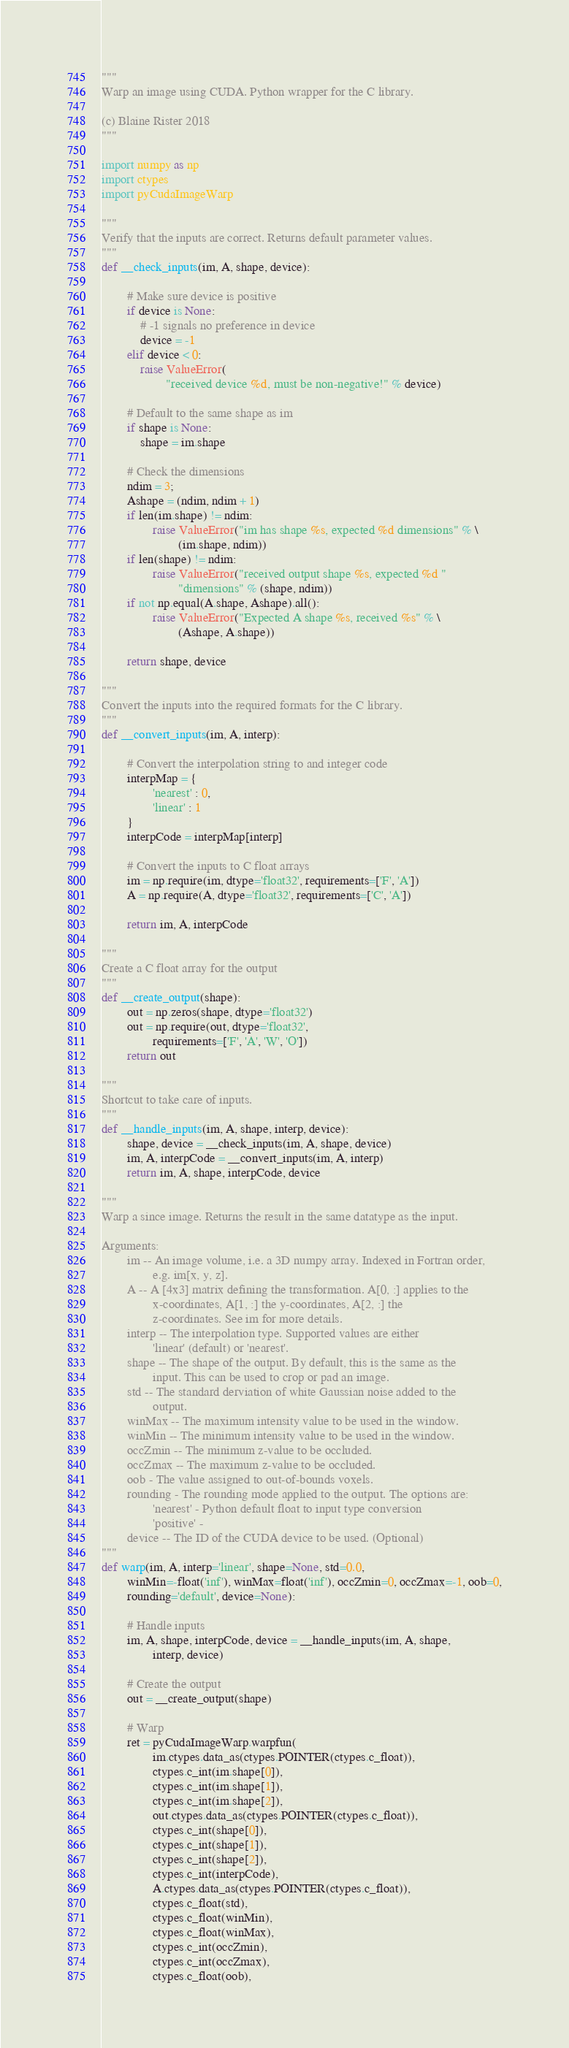<code> <loc_0><loc_0><loc_500><loc_500><_Python_>"""
Warp an image using CUDA. Python wrapper for the C library.

(c) Blaine Rister 2018
"""

import numpy as np
import ctypes
import pyCudaImageWarp

"""
Verify that the inputs are correct. Returns default parameter values.
"""
def __check_inputs(im, A, shape, device):

        # Make sure device is positive
        if device is None:
            # -1 signals no preference in device
            device = -1
        elif device < 0:
            raise ValueError(
                    "received device %d, must be non-negative!" % device)

        # Default to the same shape as im
        if shape is None:
            shape = im.shape

        # Check the dimensions
        ndim = 3;
        Ashape = (ndim, ndim + 1)
        if len(im.shape) != ndim:
                raise ValueError("im has shape %s, expected %d dimensions" % \
                        (im.shape, ndim))
        if len(shape) != ndim:
                raise ValueError("received output shape %s, expected %d "
                        "dimensions" % (shape, ndim))
        if not np.equal(A.shape, Ashape).all():
                raise ValueError("Expected A shape %s, received %s" % \
                        (Ashape, A.shape))

        return shape, device

""" 
Convert the inputs into the required formats for the C library.
"""
def __convert_inputs(im, A, interp):

        # Convert the interpolation string to and integer code
        interpMap = {
                'nearest' : 0,
                'linear' : 1
        }
        interpCode = interpMap[interp]

        # Convert the inputs to C float arrays
        im = np.require(im, dtype='float32', requirements=['F', 'A'])
        A = np.require(A, dtype='float32', requirements=['C', 'A'])

        return im, A, interpCode

"""
Create a C float array for the output
"""
def __create_output(shape):
        out = np.zeros(shape, dtype='float32')
        out = np.require(out, dtype='float32', 
                requirements=['F', 'A', 'W', 'O'])
        return out

"""
Shortcut to take care of inputs.
"""
def __handle_inputs(im, A, shape, interp, device):
        shape, device = __check_inputs(im, A, shape, device)
        im, A, interpCode = __convert_inputs(im, A, interp)
        return im, A, shape, interpCode, device

"""
Warp a since image. Returns the result in the same datatype as the input.

Arguments:
        im -- An image volume, i.e. a 3D numpy array. Indexed in Fortran order,
                e.g. im[x, y, z].
        A -- A [4x3] matrix defining the transformation. A[0, :] applies to the
                x-coordinates, A[1, :] the y-coordinates, A[2, :] the 
                z-coordinates. See im for more details.
        interp -- The interpolation type. Supported values are either 
                'linear' (default) or 'nearest'.
        shape -- The shape of the output. By default, this is the same as the 
                input. This can be used to crop or pad an image.
        std -- The standard derviation of white Gaussian noise added to the
                output.
        winMax -- The maximum intensity value to be used in the window.
        winMin -- The minimum intensity value to be used in the window.
        occZmin -- The minimum z-value to be occluded.
        occZmax -- The maximum z-value to be occluded.
        oob - The value assigned to out-of-bounds voxels.
        rounding - The rounding mode applied to the output. The options are:
                'nearest' - Python default float to input type conversion
                'positive' - 
        device -- The ID of the CUDA device to be used. (Optional)
"""
def warp(im, A, interp='linear', shape=None, std=0.0, 
        winMin=-float('inf'), winMax=float('inf'), occZmin=0, occZmax=-1, oob=0,
        rounding='default', device=None):

        # Handle inputs
        im, A, shape, interpCode, device = __handle_inputs(im, A, shape,
                interp, device)

        # Create the output
        out = __create_output(shape)

        # Warp
        ret = pyCudaImageWarp.warpfun(
                im.ctypes.data_as(ctypes.POINTER(ctypes.c_float)),
                ctypes.c_int(im.shape[0]), 
                ctypes.c_int(im.shape[1]), 
                ctypes.c_int(im.shape[2]), 
                out.ctypes.data_as(ctypes.POINTER(ctypes.c_float)),
                ctypes.c_int(shape[0]),
                ctypes.c_int(shape[1]),
                ctypes.c_int(shape[2]),
                ctypes.c_int(interpCode),
                A.ctypes.data_as(ctypes.POINTER(ctypes.c_float)),
                ctypes.c_float(std),
                ctypes.c_float(winMin),
                ctypes.c_float(winMax),
                ctypes.c_int(occZmin),
                ctypes.c_int(occZmax),
                ctypes.c_float(oob),</code> 